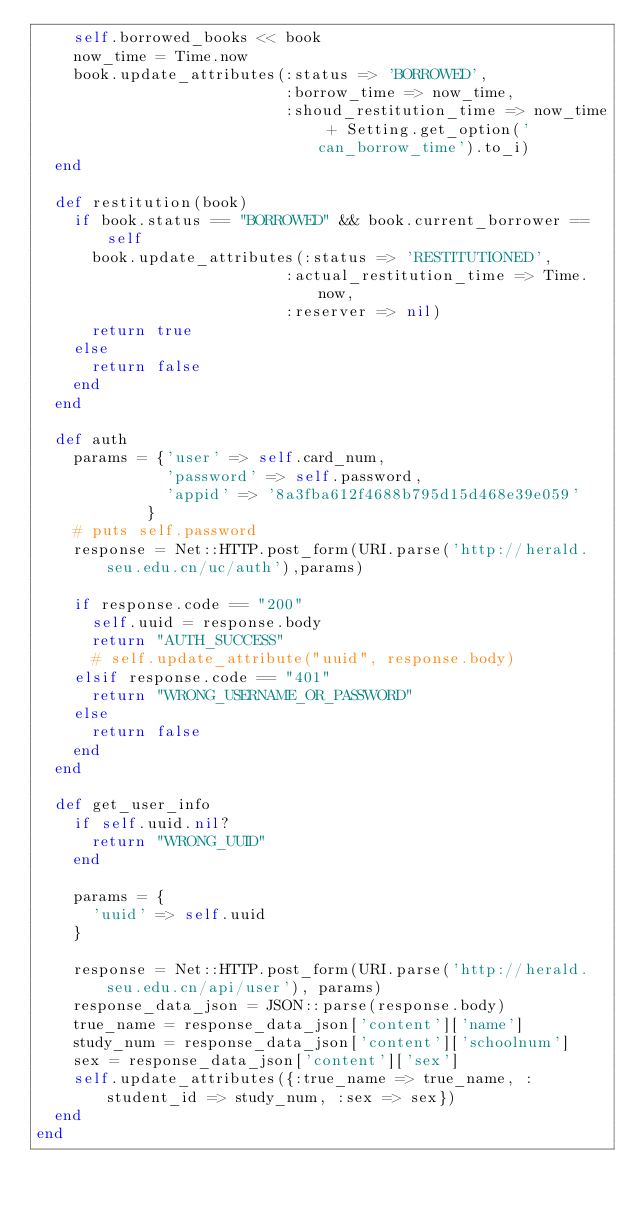Convert code to text. <code><loc_0><loc_0><loc_500><loc_500><_Ruby_>    self.borrowed_books << book
    now_time = Time.now
    book.update_attributes(:status => 'BORROWED', 
                           :borrow_time => now_time, 
                           :shoud_restitution_time => now_time + Setting.get_option('can_borrow_time').to_i)
  end

  def restitution(book)
    if book.status == "BORROWED" && book.current_borrower == self
      book.update_attributes(:status => 'RESTITUTIONED', 
                           :actual_restitution_time => Time.now,
                           :reserver => nil)
      return true
    else
      return false
    end
  end

  def auth
    params = {'user' => self.card_num, 
              'password' => self.password, 
              'appid' => '8a3fba612f4688b795d15d468e39e059'
            }
    # puts self.password
    response = Net::HTTP.post_form(URI.parse('http://herald.seu.edu.cn/uc/auth'),params)

    if response.code == "200"
      self.uuid = response.body
      return "AUTH_SUCCESS"
      # self.update_attribute("uuid", response.body)
    elsif response.code == "401"
      return "WRONG_USERNAME_OR_PASSWORD"
    else
      return false
    end
  end

  def get_user_info
    if self.uuid.nil?
      return "WRONG_UUID"
    end

    params = {
      'uuid' => self.uuid
    }

    response = Net::HTTP.post_form(URI.parse('http://herald.seu.edu.cn/api/user'), params)
    response_data_json = JSON::parse(response.body)
    true_name = response_data_json['content']['name']
    study_num = response_data_json['content']['schoolnum']
    sex = response_data_json['content']['sex']
    self.update_attributes({:true_name => true_name, :student_id => study_num, :sex => sex})
  end
end
</code> 